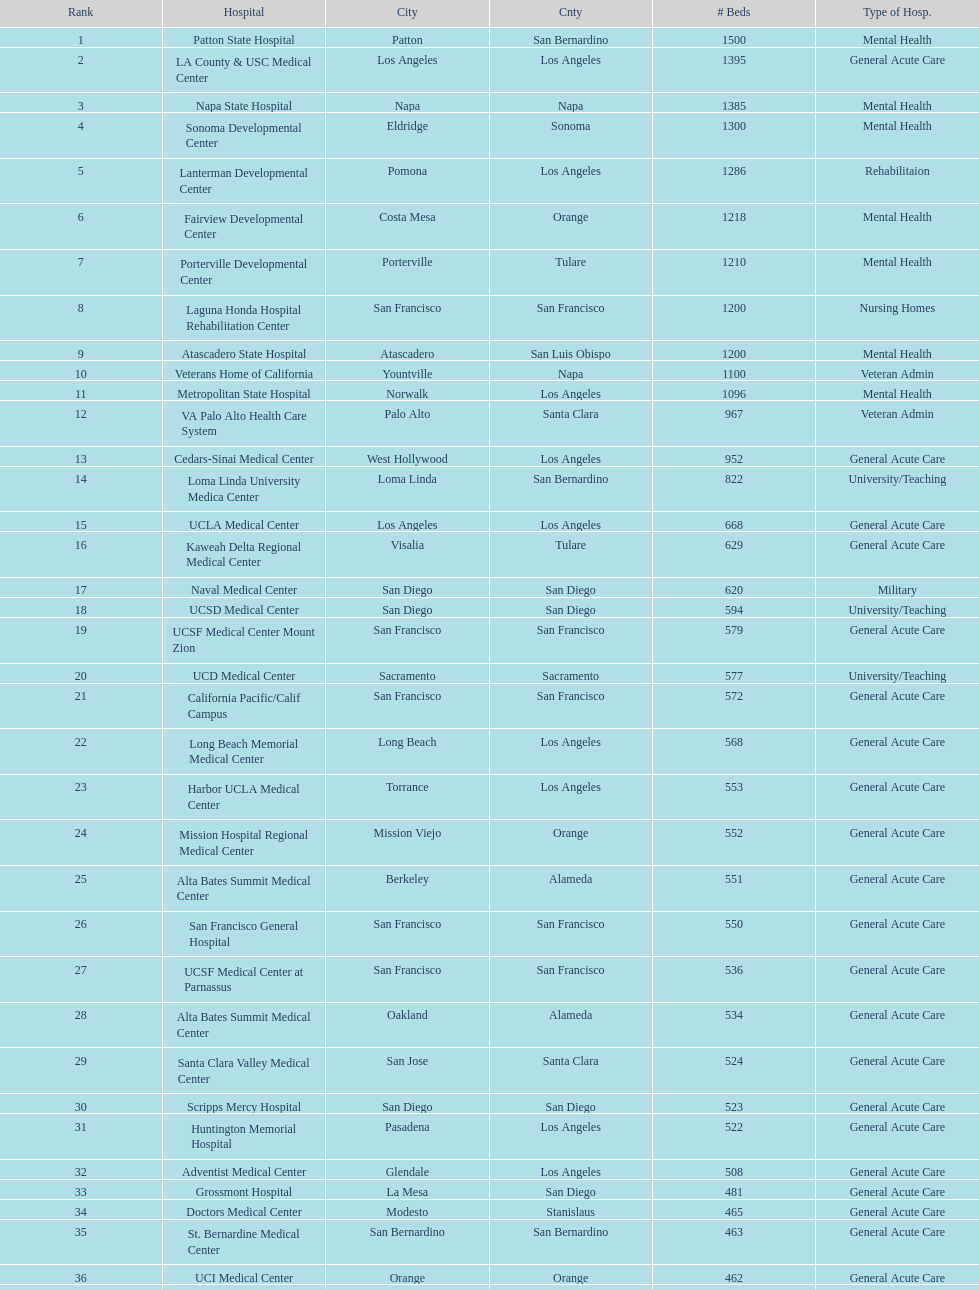Does patton state hospital in the city of patton in san bernardino county have more mental health hospital beds than atascadero state hospital in atascadero, san luis obispo county? Yes. 